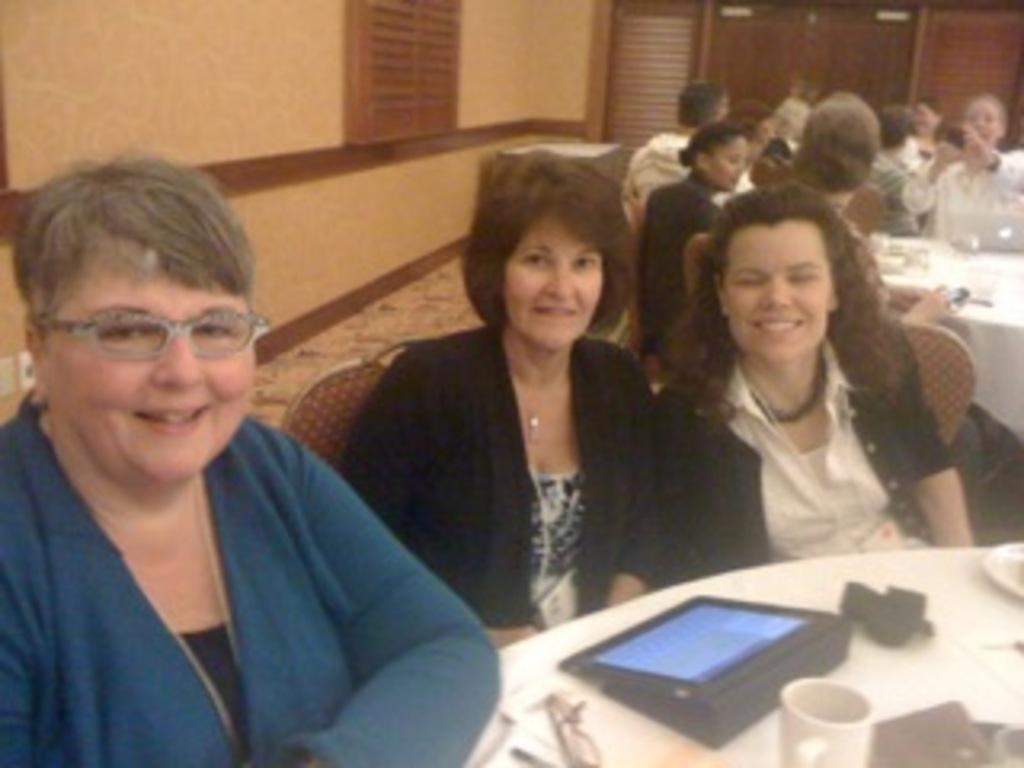How would you summarize this image in a sentence or two? In this picture we can see a group of people sitting on chairs and smiling and in front of them on tables we can see a spectacle, cup and some objects and in the background we can see the wall, window, doors. 